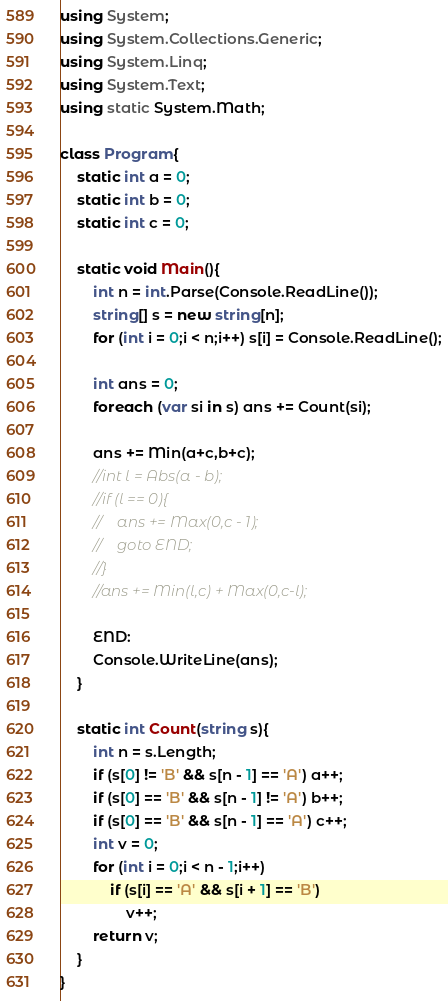<code> <loc_0><loc_0><loc_500><loc_500><_C#_>using System;
using System.Collections.Generic;
using System.Linq;
using System.Text;
using static System.Math;

class Program{
    static int a = 0;
    static int b = 0;
    static int c = 0;

    static void Main(){
        int n = int.Parse(Console.ReadLine());
        string[] s = new string[n];
        for (int i = 0;i < n;i++) s[i] = Console.ReadLine();

        int ans = 0;
        foreach (var si in s) ans += Count(si);

        ans += Min(a+c,b+c);
        //int l = Abs(a - b);
        //if (l == 0){
        //    ans += Max(0,c - 1);
        //    goto END;
        //}
        //ans += Min(l,c) + Max(0,c-l);
    
        END:
        Console.WriteLine(ans);
    }

    static int Count(string s){
        int n = s.Length;
        if (s[0] != 'B' && s[n - 1] == 'A') a++;
        if (s[0] == 'B' && s[n - 1] != 'A') b++;
        if (s[0] == 'B' && s[n - 1] == 'A') c++;
        int v = 0;
        for (int i = 0;i < n - 1;i++)
            if (s[i] == 'A' && s[i + 1] == 'B')
                v++;
        return v;
    }
}</code> 